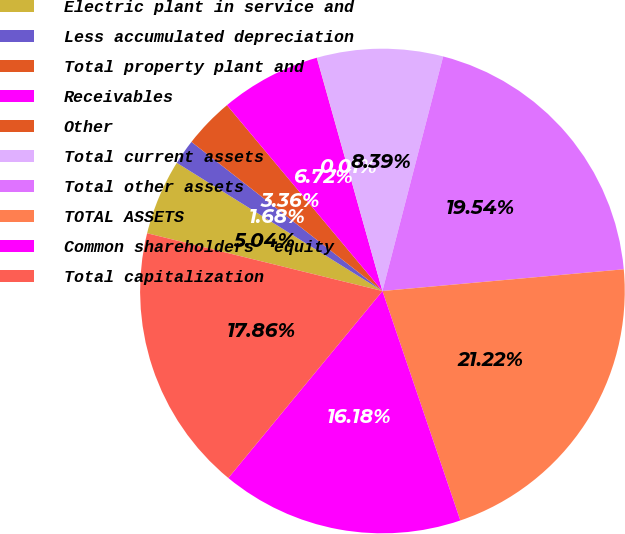Convert chart to OTSL. <chart><loc_0><loc_0><loc_500><loc_500><pie_chart><fcel>Electric plant in service and<fcel>Less accumulated depreciation<fcel>Total property plant and<fcel>Receivables<fcel>Other<fcel>Total current assets<fcel>Total other assets<fcel>TOTAL ASSETS<fcel>Common shareholders' equity<fcel>Total capitalization<nl><fcel>5.04%<fcel>1.68%<fcel>3.36%<fcel>6.72%<fcel>0.01%<fcel>8.39%<fcel>19.54%<fcel>21.22%<fcel>16.18%<fcel>17.86%<nl></chart> 